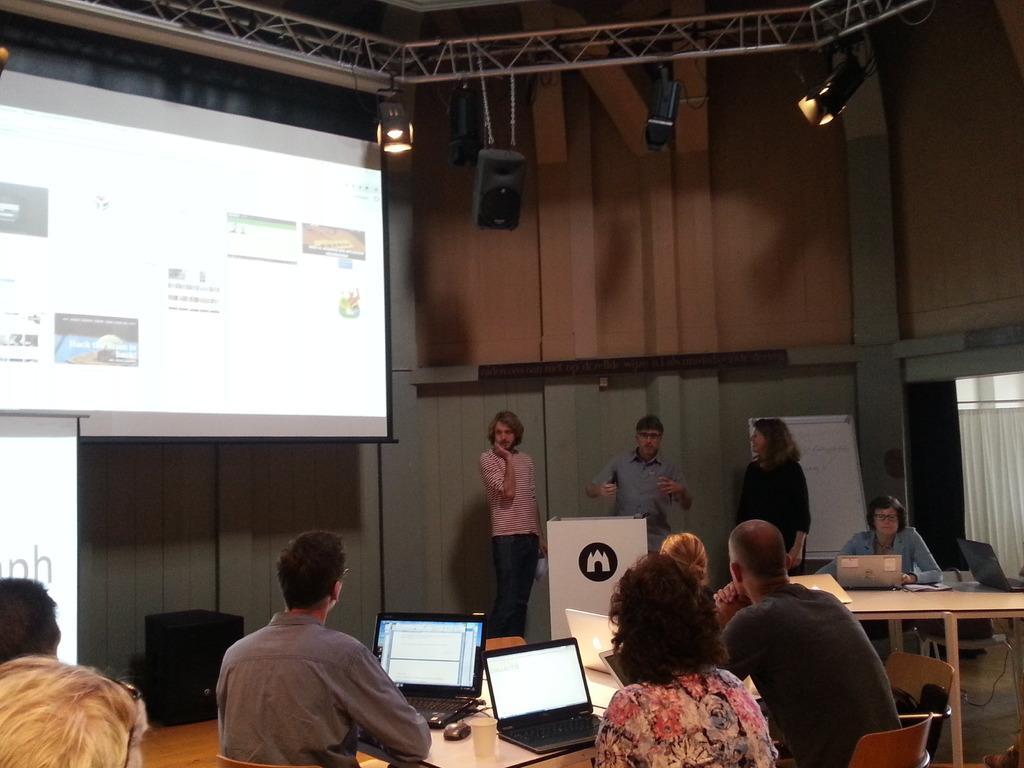How would you summarize this image in a sentence or two? This image is taken in a conference hall. Here, we see many people sitting on chair and listening to the man on the opposite side who is wearing blue shirt. In front of him, we see a white board. In front of the picture, we see a table on which laptop, glass, mouse and papers are placed. On the right top of the picture, we see a projector screen which is displaying icons and text on it. 